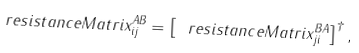Convert formula to latex. <formula><loc_0><loc_0><loc_500><loc_500>\ r e s i s t a n c e M a t r i x ^ { A B } _ { i j } = \left [ \ r e s i s t a n c e M a t r i x ^ { B A } _ { j i } \right ] ^ { \dagger } ,</formula> 